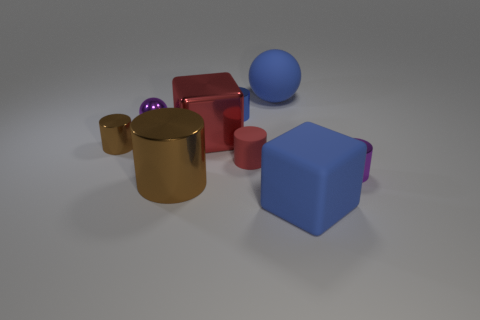Subtract all red cylinders. How many cylinders are left? 4 Subtract all big brown cylinders. How many cylinders are left? 4 Subtract all cyan cylinders. Subtract all brown cubes. How many cylinders are left? 5 Add 1 metallic cylinders. How many objects exist? 10 Subtract all cylinders. How many objects are left? 4 Subtract all metal objects. Subtract all small yellow metal balls. How many objects are left? 3 Add 4 red rubber things. How many red rubber things are left? 5 Add 7 large blue objects. How many large blue objects exist? 9 Subtract 0 yellow cylinders. How many objects are left? 9 